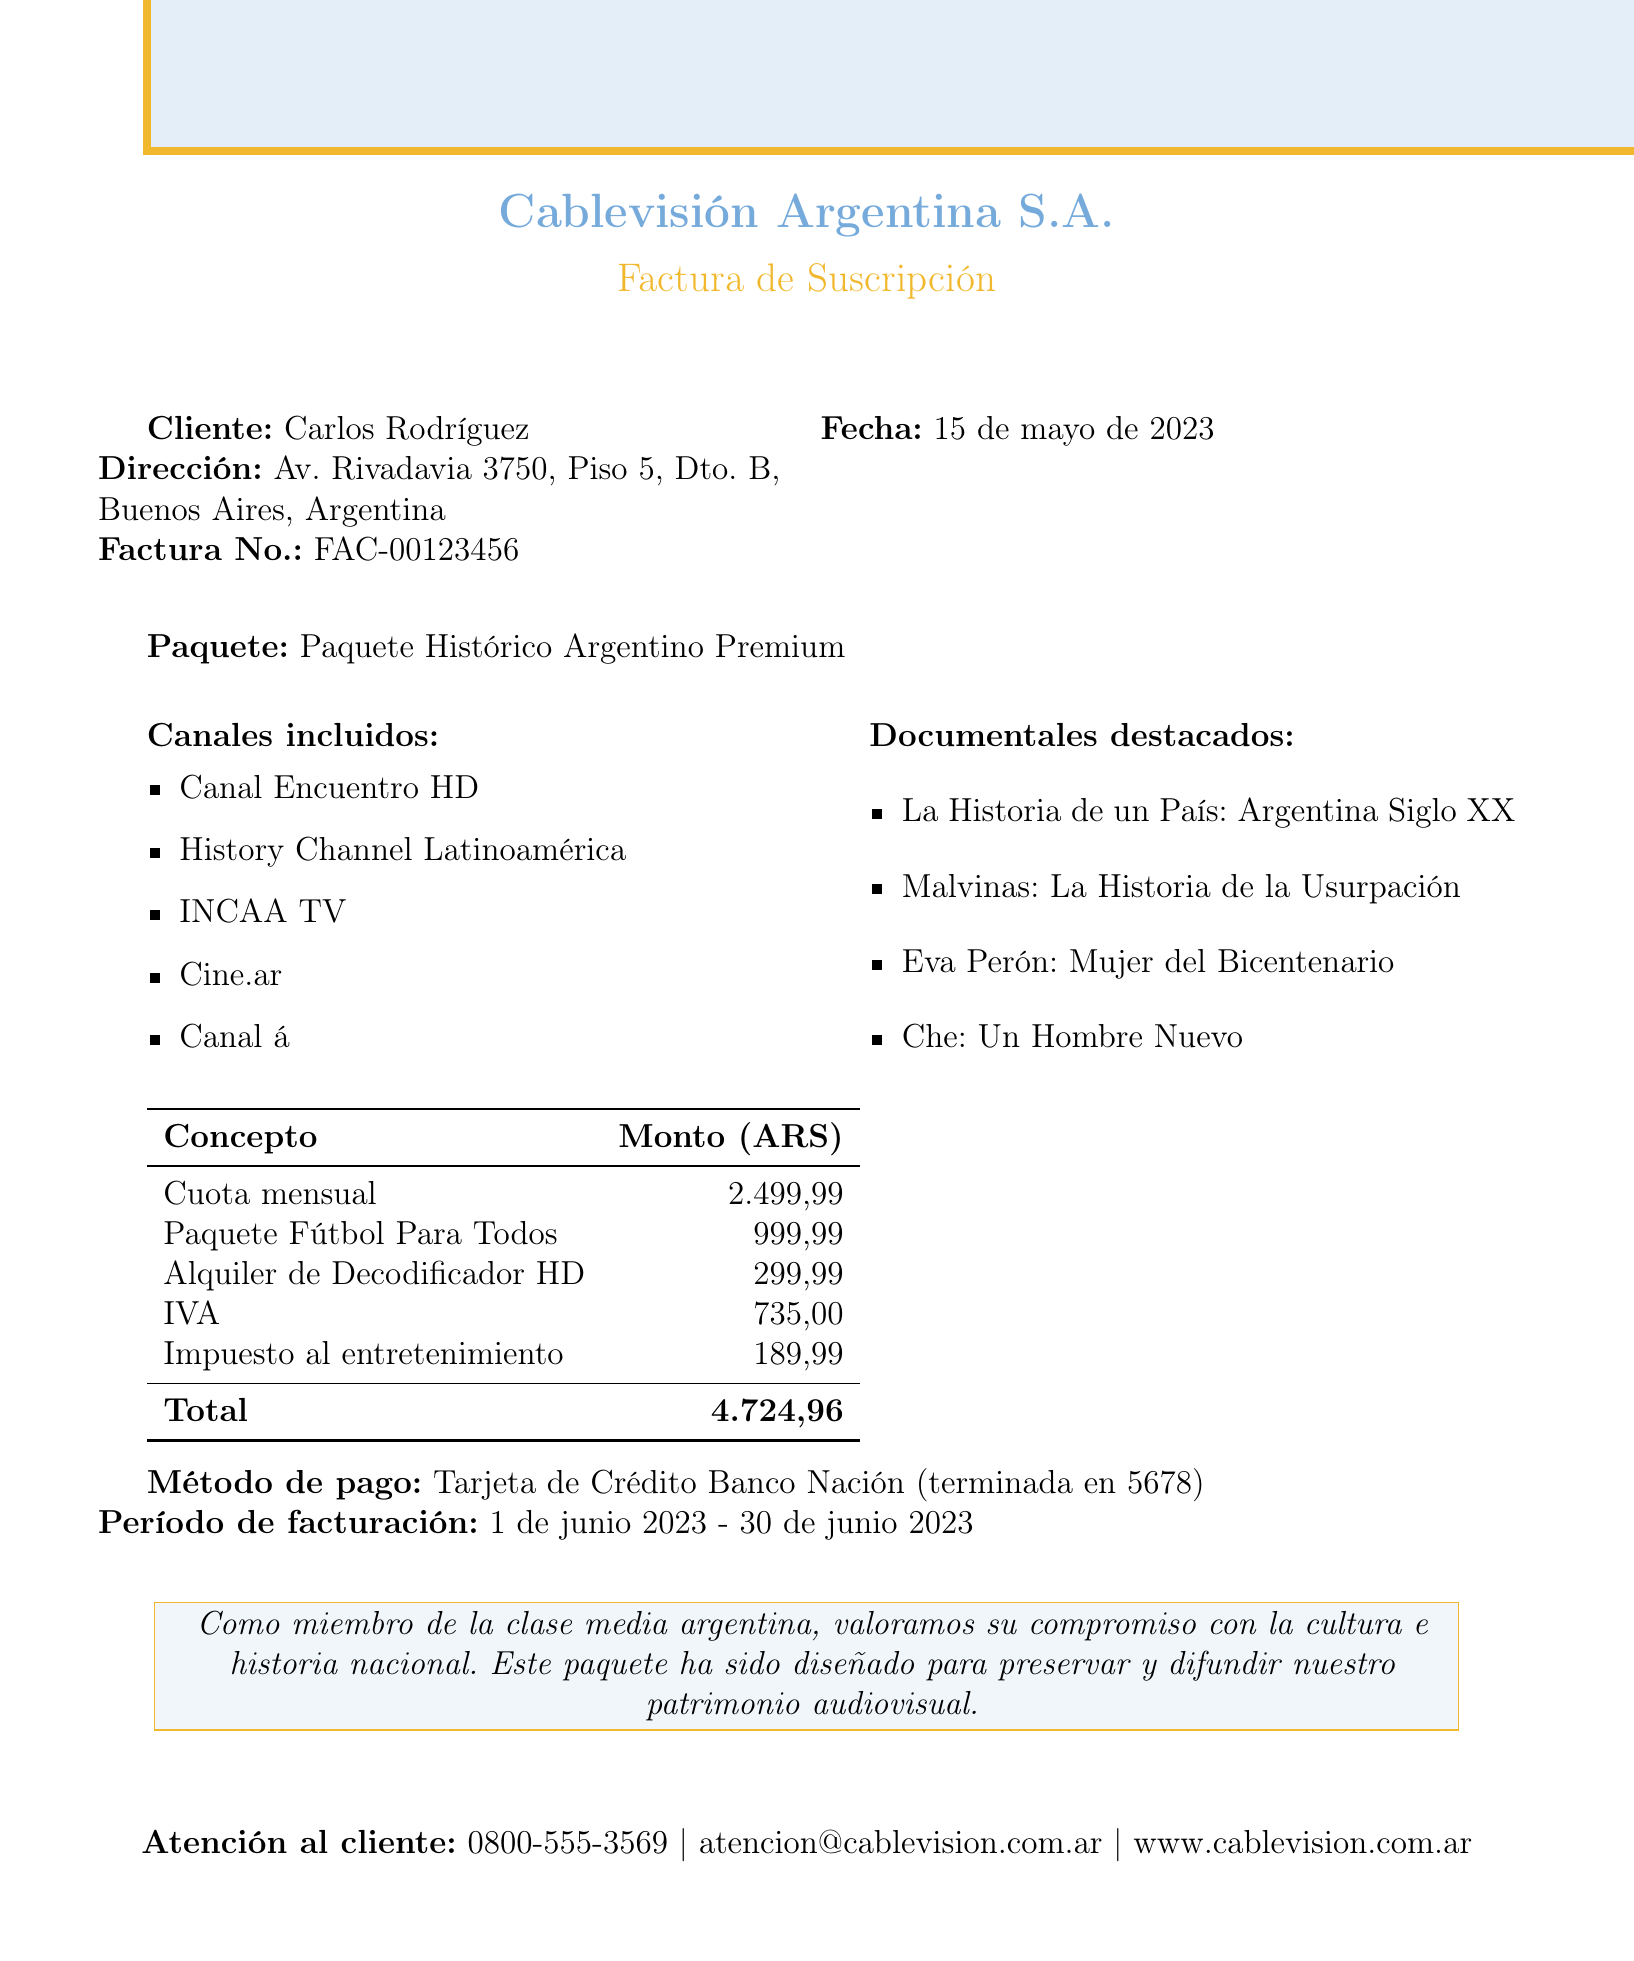What is the name of the company? The company name is clearly stated at the beginning of the document.
Answer: Cablevisión Argentina S.A Who is the customer? The document specifies the customer's name.
Answer: Carlos Rodríguez What is the invoice number? The invoice number is listed prominently in the document.
Answer: FAC-00123456 What is the date of the invoice? The date can be found in the header section of the invoice.
Answer: 15 de mayo de 2023 What is the monthly fee? The monthly fee is presented in the pricing table included in the document.
Answer: 2499.99 How many classic films are listed? The document provides a specific list of classic films, and the count can be easily determined.
Answer: 4 What is the total amount due? The total amount is shown at the end of the billing table.
Answer: 4724.96 What additional service costs 999.99? The document includes a list of additional services with their respective prices.
Answer: Paquete Fútbol Para Todos What tax is included in the invoice? The document details the taxes applied, specifically mentioning certain ones.
Answer: IVA 